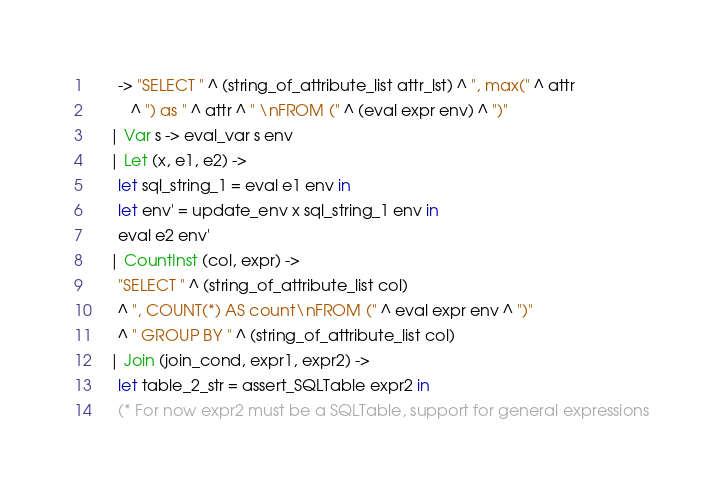Convert code to text. <code><loc_0><loc_0><loc_500><loc_500><_OCaml_>      -> "SELECT " ^ (string_of_attribute_list attr_lst) ^ ", max(" ^ attr 
         ^ ") as " ^ attr ^ " \nFROM (" ^ (eval expr env) ^ ")"
    | Var s -> eval_var s env
    | Let (x, e1, e2) -> 
      let sql_string_1 = eval e1 env in 
      let env' = update_env x sql_string_1 env in 
      eval e2 env'
    | CountInst (col, expr) ->
      "SELECT " ^ (string_of_attribute_list col) 
      ^ ", COUNT(*) AS count\nFROM (" ^ eval expr env ^ ")" 
      ^ " GROUP BY " ^ (string_of_attribute_list col) 
    | Join (join_cond, expr1, expr2) -> 
      let table_2_str = assert_SQLTable expr2 in
      (* For now expr2 must be a SQLTable, support for general expressions </code> 